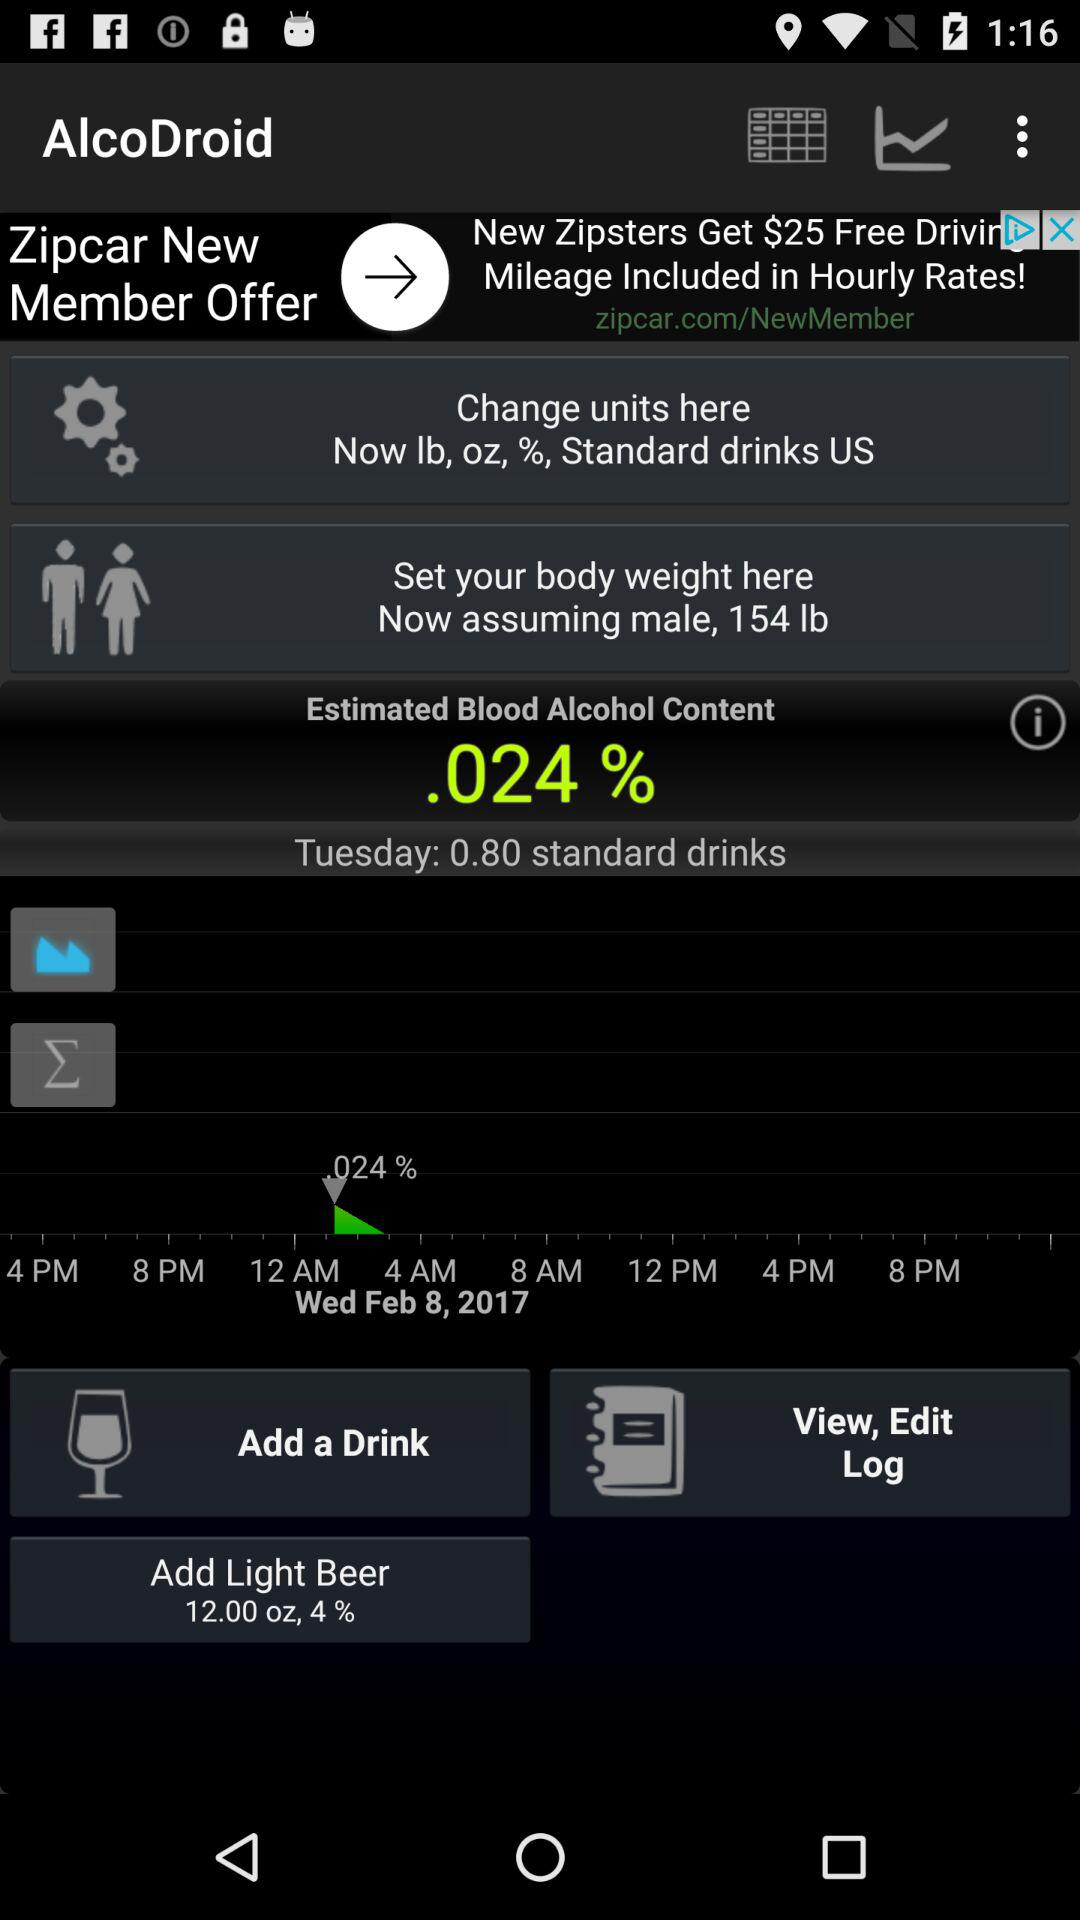What is the estimated blood alcohol content? The estimated blood alcohol content is 0.024 percent. 